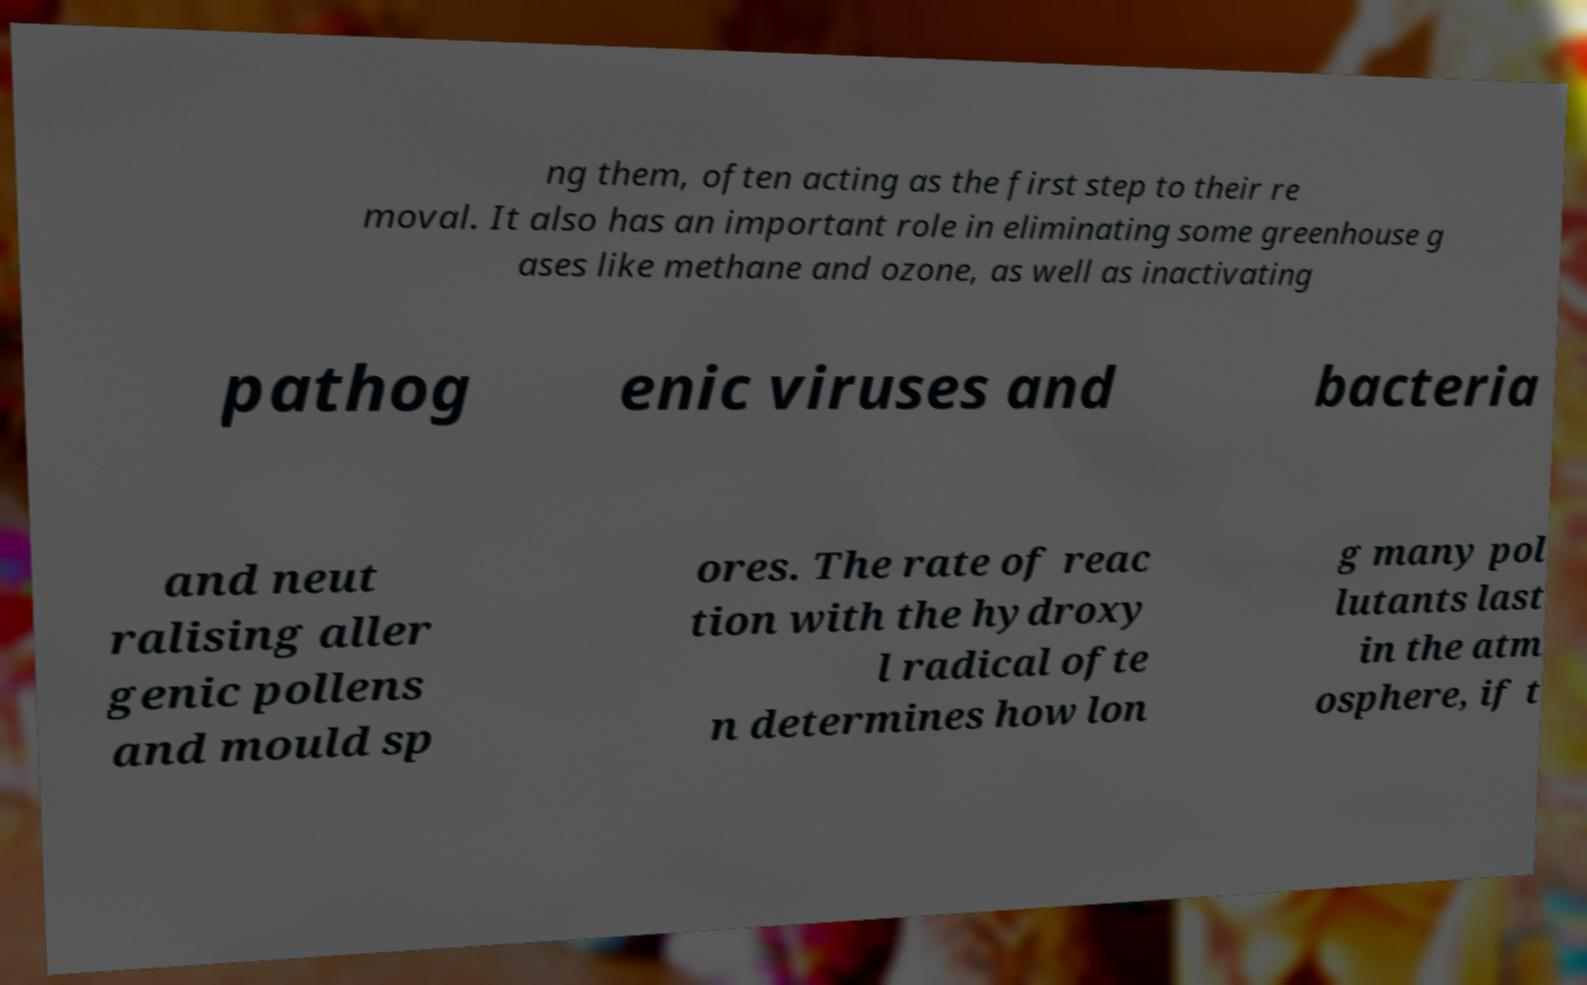For documentation purposes, I need the text within this image transcribed. Could you provide that? ng them, often acting as the first step to their re moval. It also has an important role in eliminating some greenhouse g ases like methane and ozone, as well as inactivating pathog enic viruses and bacteria and neut ralising aller genic pollens and mould sp ores. The rate of reac tion with the hydroxy l radical ofte n determines how lon g many pol lutants last in the atm osphere, if t 